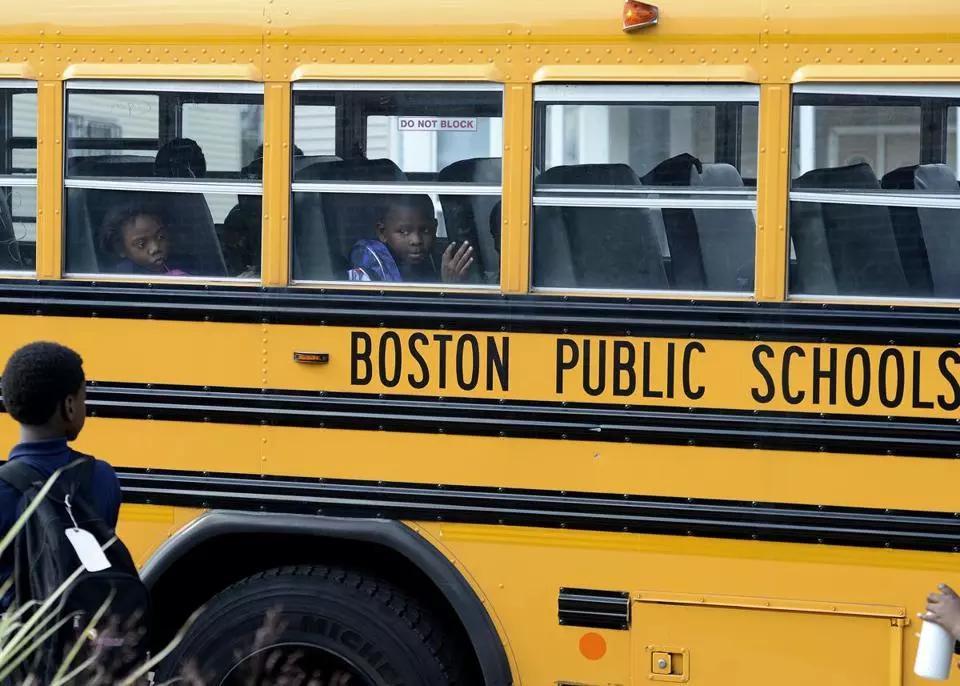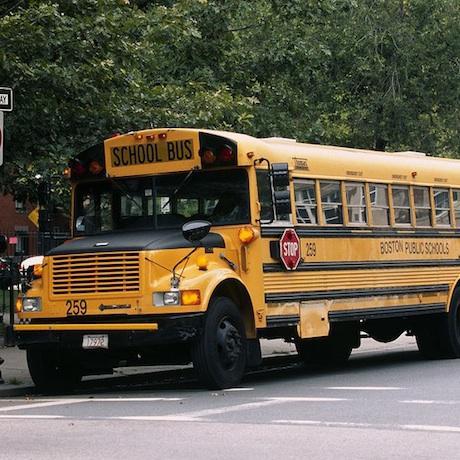The first image is the image on the left, the second image is the image on the right. Assess this claim about the two images: "In at least one image there is a single bus with a black hood facing forward left.". Correct or not? Answer yes or no. Yes. 